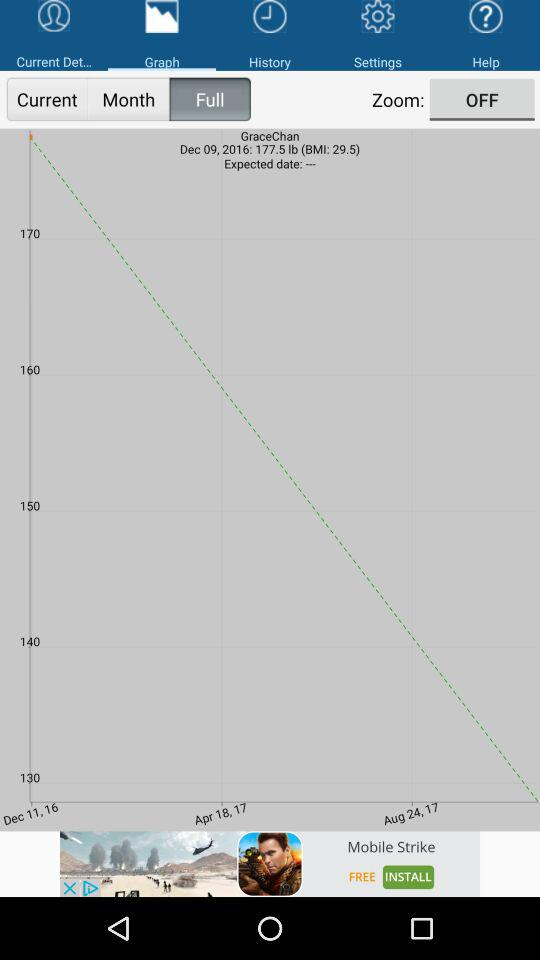What is the name of the user? The name of the user is GraceChan. 